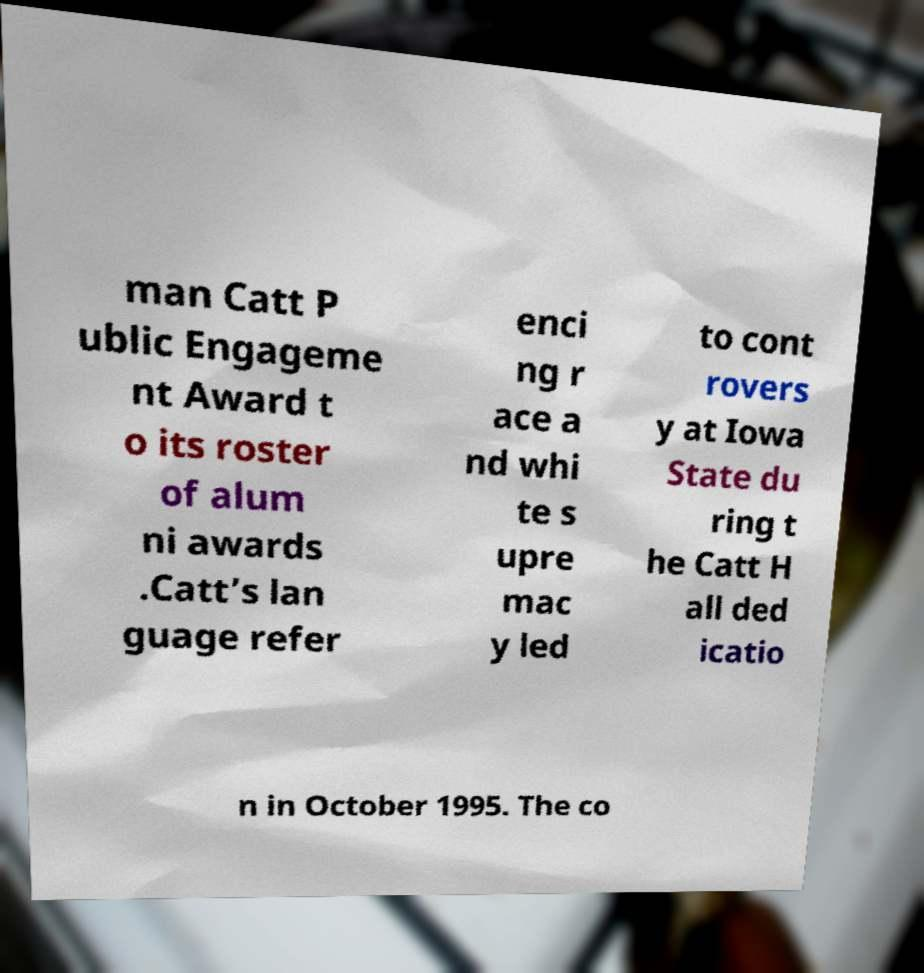For documentation purposes, I need the text within this image transcribed. Could you provide that? man Catt P ublic Engageme nt Award t o its roster of alum ni awards .Catt’s lan guage refer enci ng r ace a nd whi te s upre mac y led to cont rovers y at Iowa State du ring t he Catt H all ded icatio n in October 1995. The co 